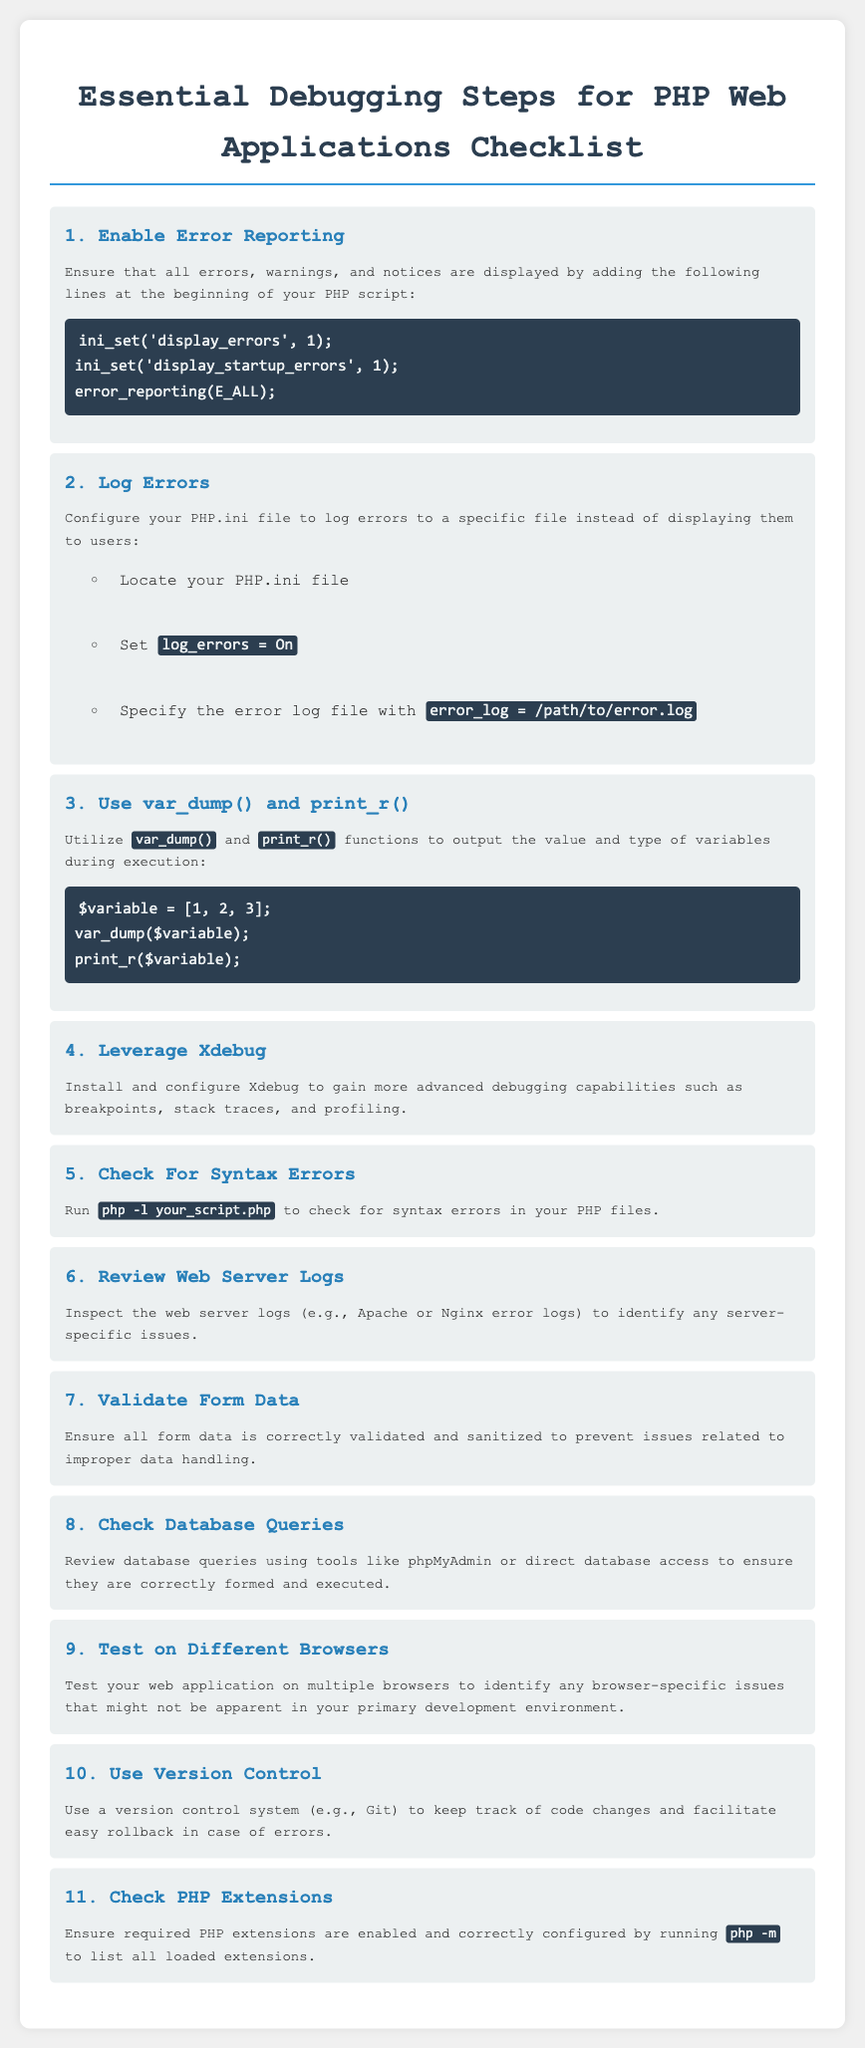What is step one in the checklist? The first step mentioned in the checklist is "Enable Error Reporting."
Answer: Enable Error Reporting How can you log errors in PHP? To log errors, you need to configure your PHP.ini file to set log_errors to On and specify the error log file path.
Answer: Configure PHP.ini Which function outputs the value and type of variables? The functions used to output the value and type of variables are var_dump and print_r.
Answer: var_dump and print_r What tool can be installed for advanced debugging capabilities? Xdebug is the tool recommended for more advanced debugging capabilities.
Answer: Xdebug How can you check for syntax errors in a PHP file? You can check for syntax errors by running the command php -l followed by the script name.
Answer: php -l your_script.php What should you inspect to identify server-specific issues? You should inspect the web server logs to identify server-specific issues.
Answer: Web server logs What is the purpose of validating form data? Validating form data helps prevent issues related to improper data handling.
Answer: Prevent improper data handling How should you handle database queries in the debugging process? Database queries should be reviewed using tools like phpMyAdmin or direct database access.
Answer: Review with phpMyAdmin What is the number of essential debugging steps listed in the checklist? The checklist lists eleven essential debugging steps.
Answer: Eleven How can you keep track of code changes? You can keep track of code changes by using a version control system like Git.
Answer: Version control system 